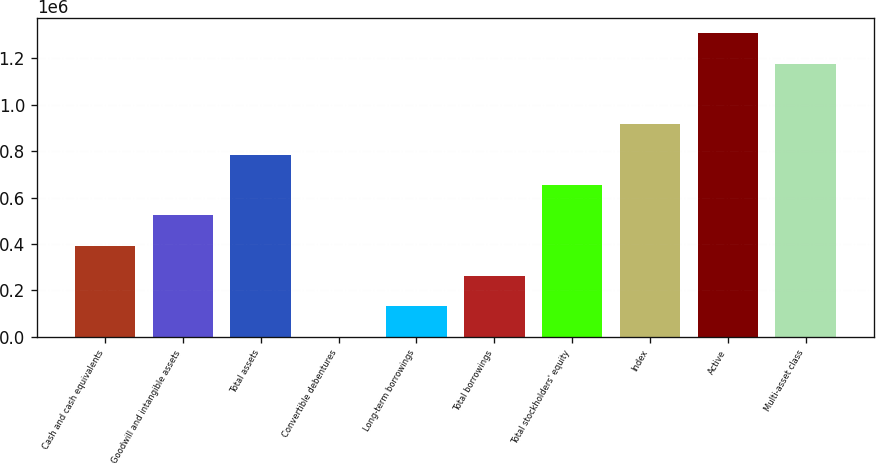Convert chart to OTSL. <chart><loc_0><loc_0><loc_500><loc_500><bar_chart><fcel>Cash and cash equivalents<fcel>Goodwill and intangible assets<fcel>Total assets<fcel>Convertible debentures<fcel>Long-term borrowings<fcel>Total borrowings<fcel>Total stockholders' equity<fcel>Index<fcel>Active<fcel>Multi-asset class<nl><fcel>392317<fcel>523007<fcel>784389<fcel>245<fcel>130936<fcel>261626<fcel>653698<fcel>915079<fcel>1.30715e+06<fcel>1.17646e+06<nl></chart> 